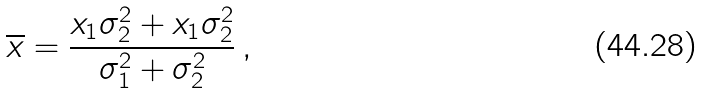<formula> <loc_0><loc_0><loc_500><loc_500>\overline { x } = \frac { x _ { 1 } \sigma _ { 2 } ^ { 2 } + x _ { 1 } \sigma _ { 2 } ^ { 2 } } { \sigma _ { 1 } ^ { 2 } + \sigma _ { 2 } ^ { 2 } } \, ,</formula> 